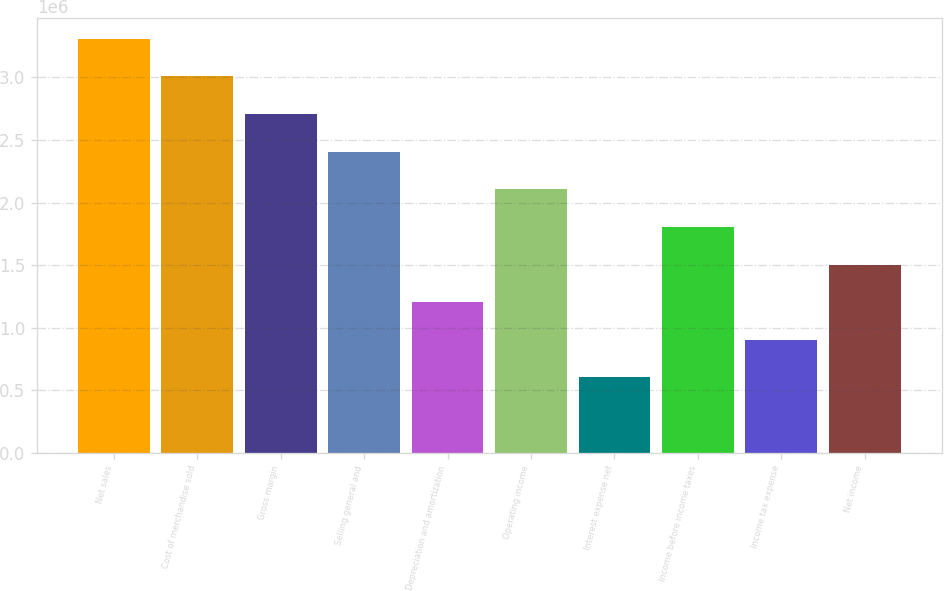Convert chart to OTSL. <chart><loc_0><loc_0><loc_500><loc_500><bar_chart><fcel>Net sales<fcel>Cost of merchandise sold<fcel>Gross margin<fcel>Selling general and<fcel>Depreciation and amortization<fcel>Operating income<fcel>Interest expense net<fcel>Income before income taxes<fcel>Income tax expense<fcel>Net income<nl><fcel>3.30874e+06<fcel>3.00795e+06<fcel>2.70715e+06<fcel>2.40636e+06<fcel>1.20318e+06<fcel>2.10556e+06<fcel>601592<fcel>1.80477e+06<fcel>902386<fcel>1.50398e+06<nl></chart> 